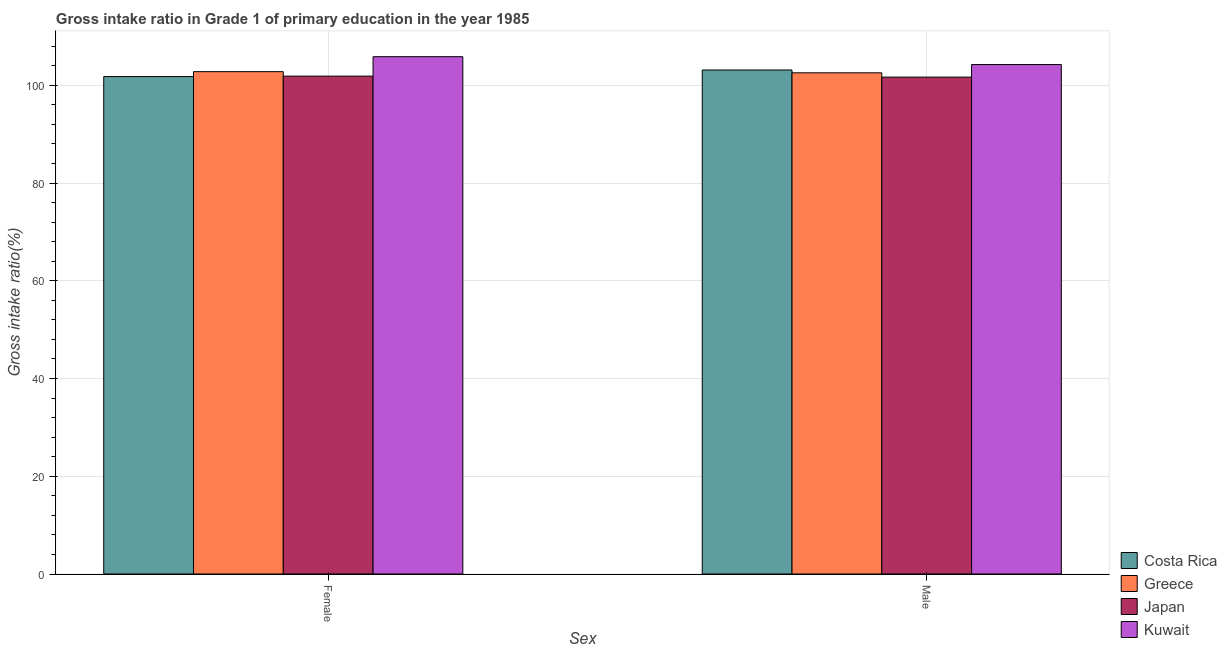How many groups of bars are there?
Make the answer very short. 2. Are the number of bars per tick equal to the number of legend labels?
Your answer should be very brief. Yes. Are the number of bars on each tick of the X-axis equal?
Ensure brevity in your answer.  Yes. What is the label of the 2nd group of bars from the left?
Offer a very short reply. Male. What is the gross intake ratio(male) in Japan?
Give a very brief answer. 101.69. Across all countries, what is the maximum gross intake ratio(female)?
Provide a succinct answer. 105.86. Across all countries, what is the minimum gross intake ratio(male)?
Give a very brief answer. 101.69. In which country was the gross intake ratio(female) maximum?
Provide a short and direct response. Kuwait. In which country was the gross intake ratio(female) minimum?
Your answer should be compact. Costa Rica. What is the total gross intake ratio(male) in the graph?
Offer a terse response. 411.64. What is the difference between the gross intake ratio(male) in Kuwait and that in Japan?
Your answer should be very brief. 2.57. What is the difference between the gross intake ratio(male) in Japan and the gross intake ratio(female) in Greece?
Provide a short and direct response. -1.11. What is the average gross intake ratio(female) per country?
Provide a short and direct response. 103.09. What is the difference between the gross intake ratio(male) and gross intake ratio(female) in Japan?
Your answer should be very brief. -0.2. What is the ratio of the gross intake ratio(female) in Japan to that in Greece?
Ensure brevity in your answer.  0.99. Is the gross intake ratio(female) in Kuwait less than that in Japan?
Ensure brevity in your answer.  No. What does the 4th bar from the left in Female represents?
Keep it short and to the point. Kuwait. What does the 1st bar from the right in Male represents?
Offer a very short reply. Kuwait. Are all the bars in the graph horizontal?
Make the answer very short. No. Does the graph contain any zero values?
Ensure brevity in your answer.  No. How many legend labels are there?
Provide a short and direct response. 4. What is the title of the graph?
Make the answer very short. Gross intake ratio in Grade 1 of primary education in the year 1985. Does "Libya" appear as one of the legend labels in the graph?
Your response must be concise. No. What is the label or title of the X-axis?
Give a very brief answer. Sex. What is the label or title of the Y-axis?
Give a very brief answer. Gross intake ratio(%). What is the Gross intake ratio(%) in Costa Rica in Female?
Your answer should be compact. 101.79. What is the Gross intake ratio(%) of Greece in Female?
Your answer should be compact. 102.8. What is the Gross intake ratio(%) in Japan in Female?
Provide a short and direct response. 101.89. What is the Gross intake ratio(%) of Kuwait in Female?
Give a very brief answer. 105.86. What is the Gross intake ratio(%) in Costa Rica in Male?
Ensure brevity in your answer.  103.14. What is the Gross intake ratio(%) of Greece in Male?
Your answer should be very brief. 102.56. What is the Gross intake ratio(%) in Japan in Male?
Your answer should be very brief. 101.69. What is the Gross intake ratio(%) in Kuwait in Male?
Offer a very short reply. 104.25. Across all Sex, what is the maximum Gross intake ratio(%) in Costa Rica?
Offer a terse response. 103.14. Across all Sex, what is the maximum Gross intake ratio(%) in Greece?
Your answer should be compact. 102.8. Across all Sex, what is the maximum Gross intake ratio(%) of Japan?
Give a very brief answer. 101.89. Across all Sex, what is the maximum Gross intake ratio(%) of Kuwait?
Make the answer very short. 105.86. Across all Sex, what is the minimum Gross intake ratio(%) of Costa Rica?
Offer a terse response. 101.79. Across all Sex, what is the minimum Gross intake ratio(%) of Greece?
Your answer should be compact. 102.56. Across all Sex, what is the minimum Gross intake ratio(%) of Japan?
Your answer should be very brief. 101.69. Across all Sex, what is the minimum Gross intake ratio(%) in Kuwait?
Provide a short and direct response. 104.25. What is the total Gross intake ratio(%) of Costa Rica in the graph?
Your response must be concise. 204.94. What is the total Gross intake ratio(%) of Greece in the graph?
Make the answer very short. 205.36. What is the total Gross intake ratio(%) of Japan in the graph?
Keep it short and to the point. 203.57. What is the total Gross intake ratio(%) of Kuwait in the graph?
Give a very brief answer. 210.11. What is the difference between the Gross intake ratio(%) of Costa Rica in Female and that in Male?
Offer a very short reply. -1.35. What is the difference between the Gross intake ratio(%) in Greece in Female and that in Male?
Give a very brief answer. 0.24. What is the difference between the Gross intake ratio(%) of Japan in Female and that in Male?
Offer a terse response. 0.2. What is the difference between the Gross intake ratio(%) in Kuwait in Female and that in Male?
Your answer should be compact. 1.61. What is the difference between the Gross intake ratio(%) of Costa Rica in Female and the Gross intake ratio(%) of Greece in Male?
Your response must be concise. -0.77. What is the difference between the Gross intake ratio(%) of Costa Rica in Female and the Gross intake ratio(%) of Japan in Male?
Make the answer very short. 0.11. What is the difference between the Gross intake ratio(%) in Costa Rica in Female and the Gross intake ratio(%) in Kuwait in Male?
Keep it short and to the point. -2.46. What is the difference between the Gross intake ratio(%) of Greece in Female and the Gross intake ratio(%) of Japan in Male?
Make the answer very short. 1.11. What is the difference between the Gross intake ratio(%) of Greece in Female and the Gross intake ratio(%) of Kuwait in Male?
Offer a terse response. -1.45. What is the difference between the Gross intake ratio(%) in Japan in Female and the Gross intake ratio(%) in Kuwait in Male?
Provide a short and direct response. -2.36. What is the average Gross intake ratio(%) in Costa Rica per Sex?
Provide a succinct answer. 102.47. What is the average Gross intake ratio(%) in Greece per Sex?
Give a very brief answer. 102.68. What is the average Gross intake ratio(%) of Japan per Sex?
Offer a terse response. 101.79. What is the average Gross intake ratio(%) of Kuwait per Sex?
Provide a short and direct response. 105.06. What is the difference between the Gross intake ratio(%) in Costa Rica and Gross intake ratio(%) in Greece in Female?
Provide a short and direct response. -1. What is the difference between the Gross intake ratio(%) in Costa Rica and Gross intake ratio(%) in Japan in Female?
Your answer should be very brief. -0.09. What is the difference between the Gross intake ratio(%) in Costa Rica and Gross intake ratio(%) in Kuwait in Female?
Keep it short and to the point. -4.07. What is the difference between the Gross intake ratio(%) in Greece and Gross intake ratio(%) in Japan in Female?
Provide a short and direct response. 0.91. What is the difference between the Gross intake ratio(%) in Greece and Gross intake ratio(%) in Kuwait in Female?
Offer a terse response. -3.06. What is the difference between the Gross intake ratio(%) of Japan and Gross intake ratio(%) of Kuwait in Female?
Your response must be concise. -3.98. What is the difference between the Gross intake ratio(%) of Costa Rica and Gross intake ratio(%) of Greece in Male?
Your response must be concise. 0.58. What is the difference between the Gross intake ratio(%) of Costa Rica and Gross intake ratio(%) of Japan in Male?
Your answer should be very brief. 1.46. What is the difference between the Gross intake ratio(%) in Costa Rica and Gross intake ratio(%) in Kuwait in Male?
Provide a short and direct response. -1.11. What is the difference between the Gross intake ratio(%) of Greece and Gross intake ratio(%) of Japan in Male?
Offer a terse response. 0.88. What is the difference between the Gross intake ratio(%) of Greece and Gross intake ratio(%) of Kuwait in Male?
Provide a short and direct response. -1.69. What is the difference between the Gross intake ratio(%) in Japan and Gross intake ratio(%) in Kuwait in Male?
Offer a very short reply. -2.57. What is the ratio of the Gross intake ratio(%) in Costa Rica in Female to that in Male?
Your answer should be very brief. 0.99. What is the ratio of the Gross intake ratio(%) in Greece in Female to that in Male?
Ensure brevity in your answer.  1. What is the ratio of the Gross intake ratio(%) in Japan in Female to that in Male?
Provide a short and direct response. 1. What is the ratio of the Gross intake ratio(%) of Kuwait in Female to that in Male?
Your response must be concise. 1.02. What is the difference between the highest and the second highest Gross intake ratio(%) in Costa Rica?
Keep it short and to the point. 1.35. What is the difference between the highest and the second highest Gross intake ratio(%) of Greece?
Your answer should be compact. 0.24. What is the difference between the highest and the second highest Gross intake ratio(%) of Japan?
Offer a very short reply. 0.2. What is the difference between the highest and the second highest Gross intake ratio(%) in Kuwait?
Give a very brief answer. 1.61. What is the difference between the highest and the lowest Gross intake ratio(%) in Costa Rica?
Make the answer very short. 1.35. What is the difference between the highest and the lowest Gross intake ratio(%) of Greece?
Offer a very short reply. 0.24. What is the difference between the highest and the lowest Gross intake ratio(%) of Japan?
Offer a very short reply. 0.2. What is the difference between the highest and the lowest Gross intake ratio(%) in Kuwait?
Make the answer very short. 1.61. 